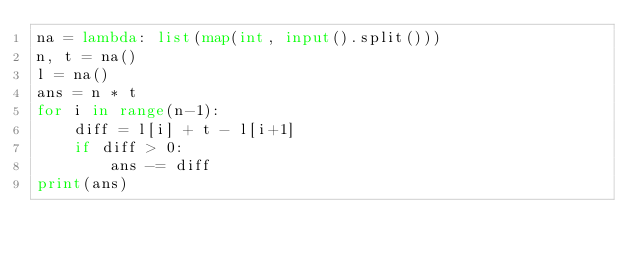<code> <loc_0><loc_0><loc_500><loc_500><_Python_>na = lambda: list(map(int, input().split()))
n, t = na()
l = na()
ans = n * t
for i in range(n-1):
    diff = l[i] + t - l[i+1]
    if diff > 0:
        ans -= diff
print(ans)</code> 